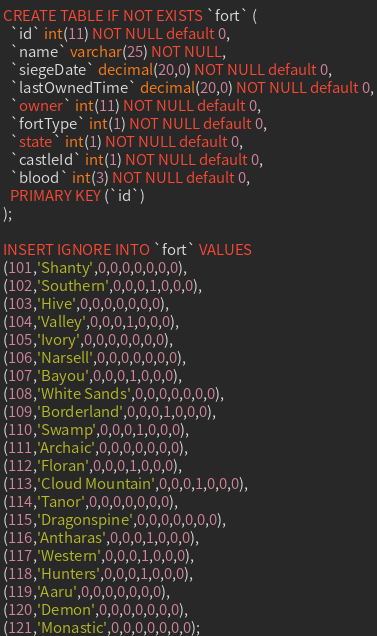Convert code to text. <code><loc_0><loc_0><loc_500><loc_500><_SQL_>CREATE TABLE IF NOT EXISTS `fort` (
  `id` int(11) NOT NULL default 0,
  `name` varchar(25) NOT NULL,
  `siegeDate` decimal(20,0) NOT NULL default 0,
  `lastOwnedTime` decimal(20,0) NOT NULL default 0,
  `owner` int(11) NOT NULL default 0,
  `fortType` int(1) NOT NULL default 0,
  `state` int(1) NOT NULL default 0,
  `castleId` int(1) NOT NULL default 0,
  `blood` int(3) NOT NULL default 0,
  PRIMARY KEY (`id`)
);

INSERT IGNORE INTO `fort` VALUES 
(101,'Shanty',0,0,0,0,0,0,0),
(102,'Southern',0,0,0,1,0,0,0),
(103,'Hive',0,0,0,0,0,0,0),
(104,'Valley',0,0,0,1,0,0,0),
(105,'Ivory',0,0,0,0,0,0,0),
(106,'Narsell',0,0,0,0,0,0,0),
(107,'Bayou',0,0,0,1,0,0,0),
(108,'White Sands',0,0,0,0,0,0,0),
(109,'Borderland',0,0,0,1,0,0,0),
(110,'Swamp',0,0,0,1,0,0,0),
(111,'Archaic',0,0,0,0,0,0,0),
(112,'Floran',0,0,0,1,0,0,0),
(113,'Cloud Mountain',0,0,0,1,0,0,0),
(114,'Tanor',0,0,0,0,0,0,0),
(115,'Dragonspine',0,0,0,0,0,0,0),
(116,'Antharas',0,0,0,1,0,0,0),
(117,'Western',0,0,0,1,0,0,0),
(118,'Hunters',0,0,0,1,0,0,0),
(119,'Aaru',0,0,0,0,0,0,0),
(120,'Demon',0,0,0,0,0,0,0),
(121,'Monastic',0,0,0,0,0,0,0);</code> 